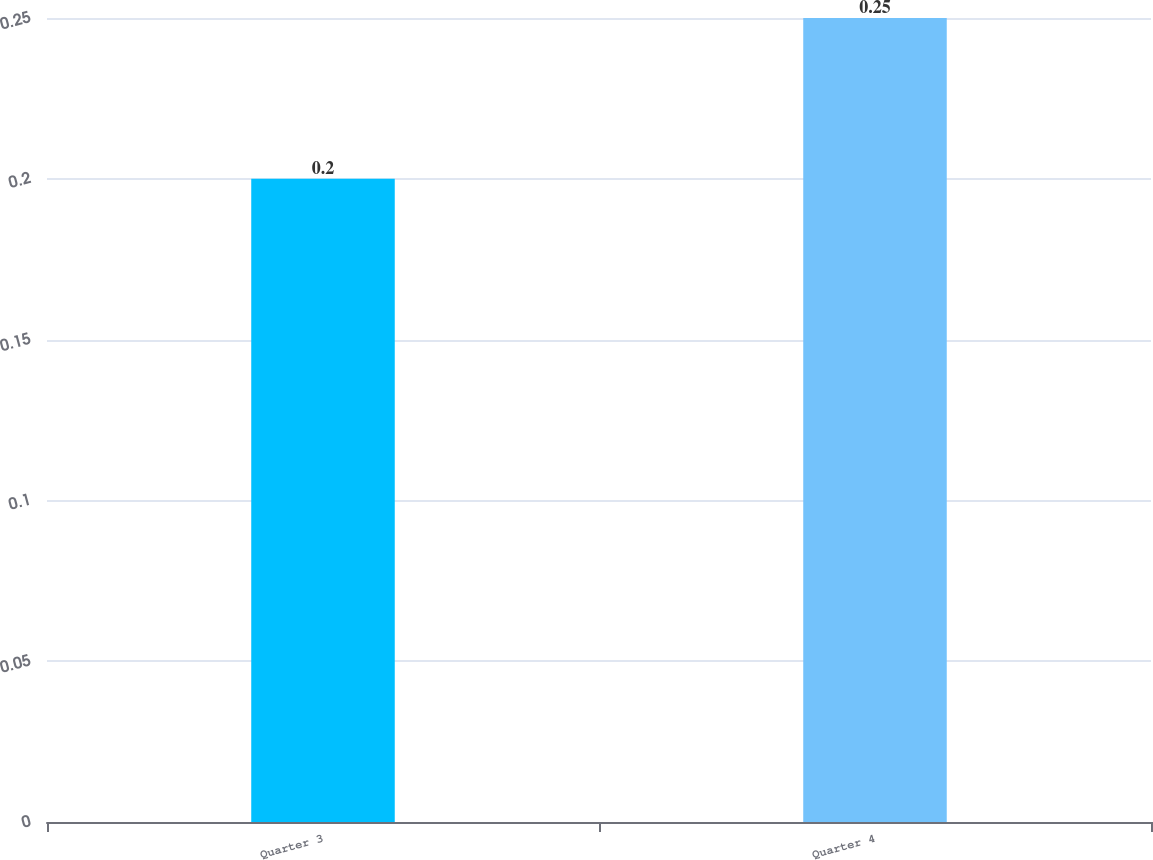<chart> <loc_0><loc_0><loc_500><loc_500><bar_chart><fcel>Quarter 3<fcel>Quarter 4<nl><fcel>0.2<fcel>0.25<nl></chart> 